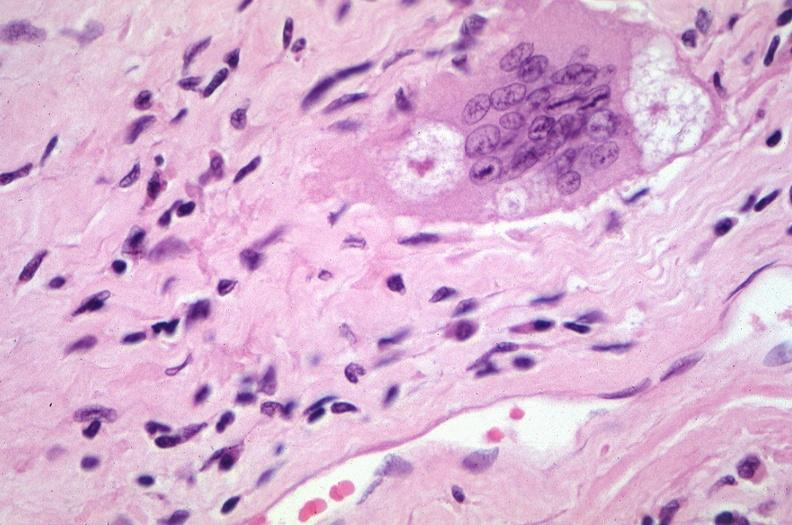what does this image show?
Answer the question using a single word or phrase. Lung 